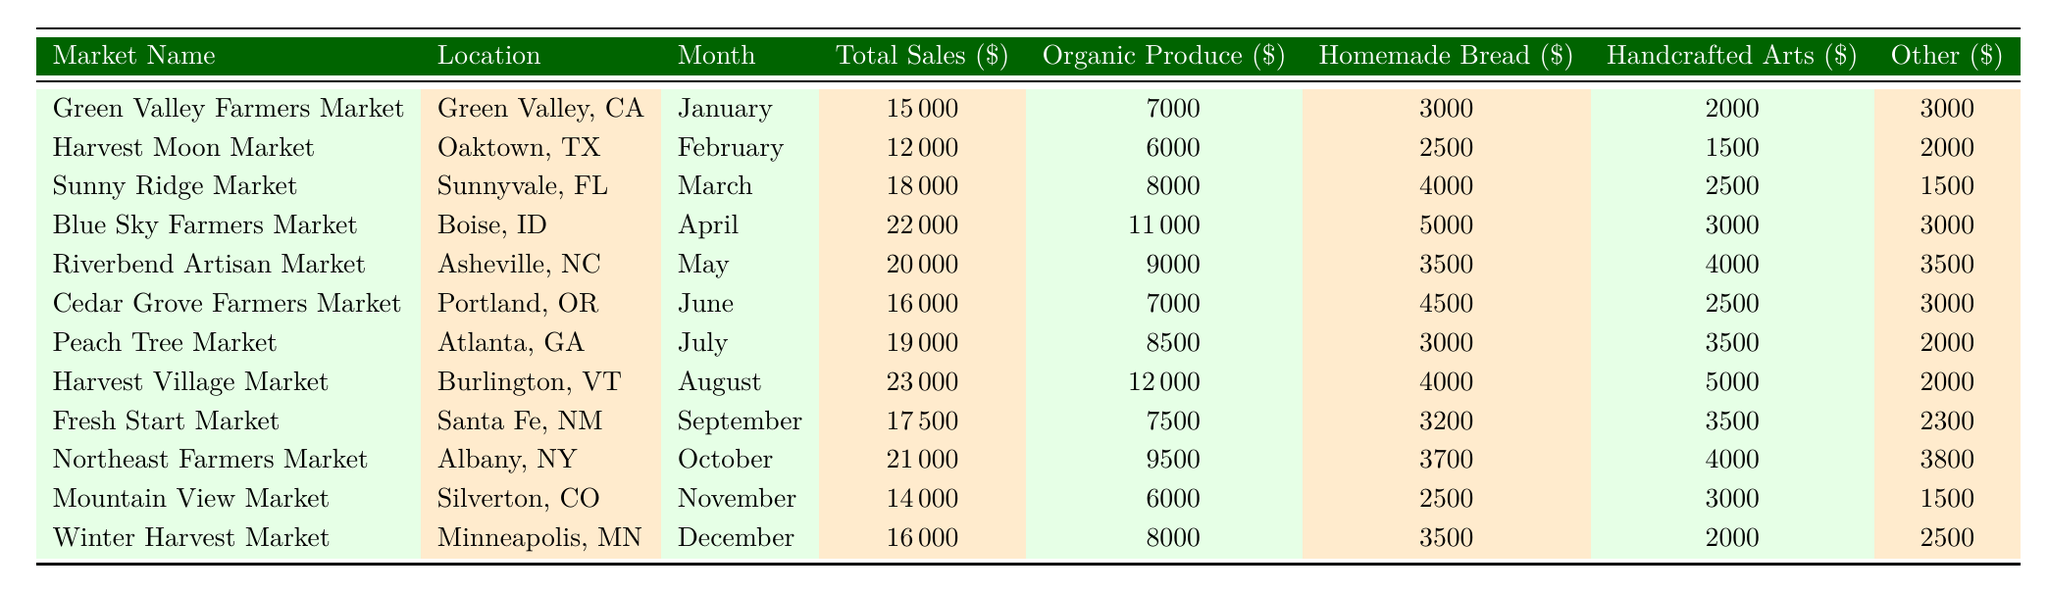What was the total sales for the Harvest Village Market in August? The table lists the total sales for the Harvest Village Market located in Burlington, VT for the month of August, which is directly given as $23,000.
Answer: 23000 Which market had the highest sales of homemade bread? By comparing the values in the "Homemade Bread" sales column, Blue Sky Farmers Market had the highest sales at $5,000 in April.
Answer: Blue Sky Farmers Market How much did the Cedar Grove Farmers Market earn in total? The total sales for Cedar Grove Farmers Market located in Portland, OR for June are listed as $16,000.
Answer: 16000 What was the average sales of organic produce across all markets? To find the average, first sum the organic produce sales from each market: 7000 + 6000 + 8000 + 11000 + 9000 + 7000 + 8500 + 12000 + 7500 + 9500 + 6000 + 8000 = 103000. There are 12 markets, so the average is 103000 / 12 = approximately 8583.33.
Answer: 8583.33 Did the total sales of the Fresh Start Market exceed $18,000? The total sales for Fresh Start Market in Santa Fe, NM for September is stated as $17,500, which is less than $18,000, therefore the statement is false.
Answer: No What is the total amount of sales from handcrafted arts in the Riverbend Artisan Market for May? The table shows that the handcrafted arts sales for Riverbend Artisan Market in May amount to $4,000.
Answer: 4000 Which market had the lowest sales overall, and what was that total? By examining the total sales column, Mountain View Market in Silverton, CO has the lowest total sales at $14,000 in November.
Answer: Mountain View Market; 14000 If we consider the sales from all markets in July and August, what is the combined total sales? The total sales in July for Peach Tree Market is $19,000 and in August for Harvest Village Market is $23,000, so the combined total is 19000 + 23000 = $42,000.
Answer: 42000 Is it true that all markets have at least $2,000 in homemade bread sales? By checking the sales for homemade bread across all markets, Mountain View Market had the lowest sales at $2,500, which confirms that the statement is true.
Answer: Yes What is the difference in total sales between the Blue Sky Farmers Market and the Harvest Moon Market? The total sales for Blue Sky Farmers Market is $22,000 and for Harvest Moon Market it is $12,000, so the difference is 22000 - 12000 = $10,000.
Answer: 10000 